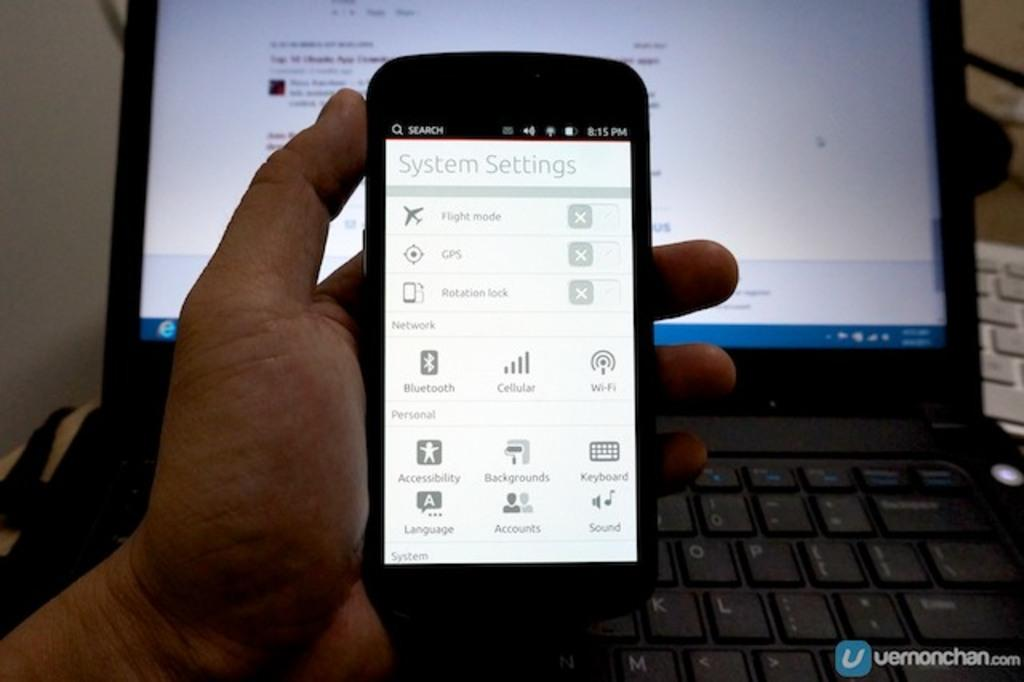Provide a one-sentence caption for the provided image. The systems setting screen of a smart phone. 